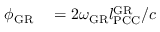<formula> <loc_0><loc_0><loc_500><loc_500>\begin{array} { r l } { \phi _ { G R } } & = 2 \omega _ { G R } l _ { P C C } ^ { G R } / c } \end{array}</formula> 